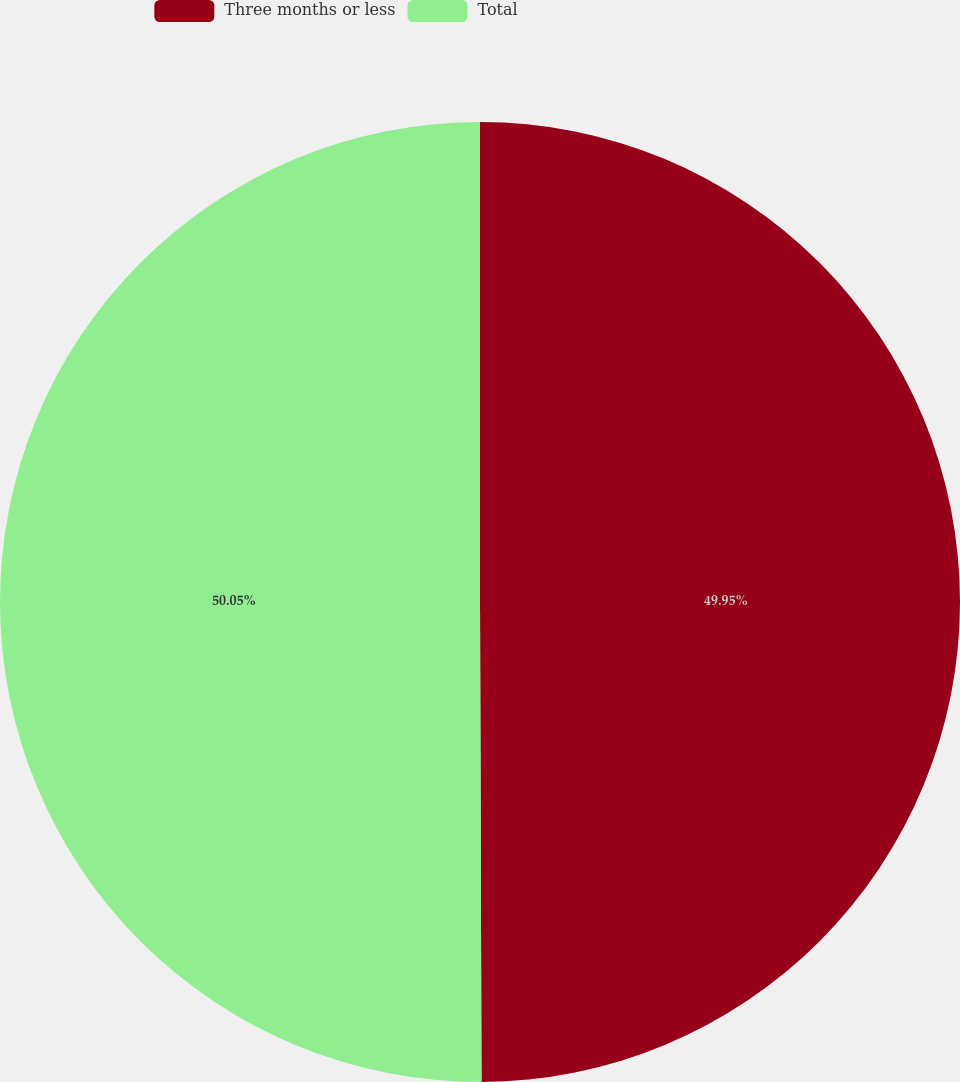<chart> <loc_0><loc_0><loc_500><loc_500><pie_chart><fcel>Three months or less<fcel>Total<nl><fcel>49.95%<fcel>50.05%<nl></chart> 